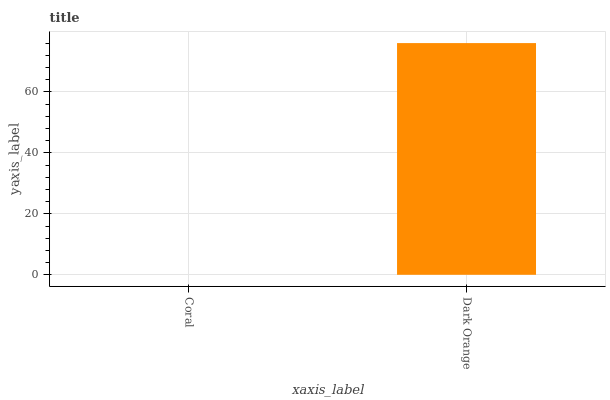Is Coral the minimum?
Answer yes or no. Yes. Is Dark Orange the maximum?
Answer yes or no. Yes. Is Dark Orange the minimum?
Answer yes or no. No. Is Dark Orange greater than Coral?
Answer yes or no. Yes. Is Coral less than Dark Orange?
Answer yes or no. Yes. Is Coral greater than Dark Orange?
Answer yes or no. No. Is Dark Orange less than Coral?
Answer yes or no. No. Is Dark Orange the high median?
Answer yes or no. Yes. Is Coral the low median?
Answer yes or no. Yes. Is Coral the high median?
Answer yes or no. No. Is Dark Orange the low median?
Answer yes or no. No. 